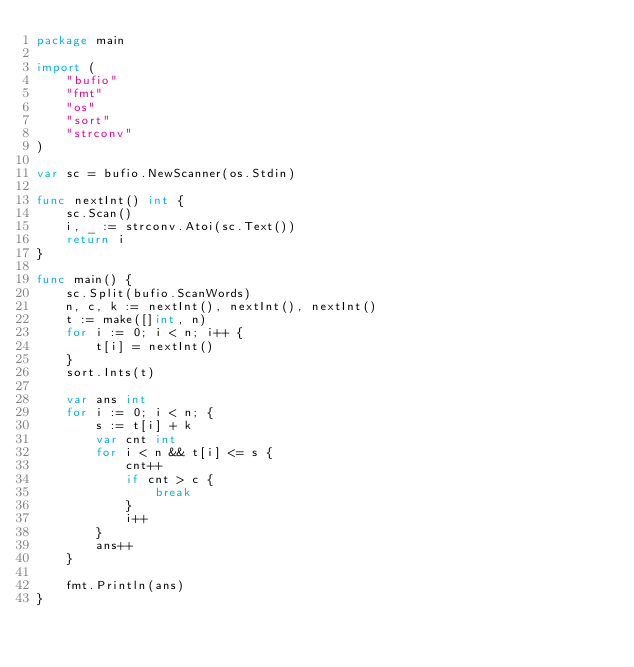<code> <loc_0><loc_0><loc_500><loc_500><_Go_>package main

import (
	"bufio"
	"fmt"
	"os"
	"sort"
	"strconv"
)

var sc = bufio.NewScanner(os.Stdin)

func nextInt() int {
	sc.Scan()
	i, _ := strconv.Atoi(sc.Text())
	return i
}

func main() {
	sc.Split(bufio.ScanWords)
	n, c, k := nextInt(), nextInt(), nextInt()
	t := make([]int, n)
	for i := 0; i < n; i++ {
		t[i] = nextInt()
	}
	sort.Ints(t)

	var ans int
	for i := 0; i < n; {
		s := t[i] + k
		var cnt int
		for i < n && t[i] <= s {
			cnt++
			if cnt > c {
				break
			}
			i++
		}
		ans++
	}

	fmt.Println(ans)
}
</code> 